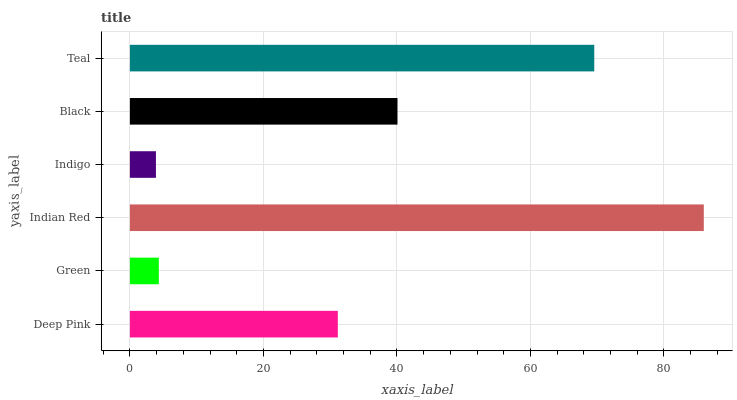Is Indigo the minimum?
Answer yes or no. Yes. Is Indian Red the maximum?
Answer yes or no. Yes. Is Green the minimum?
Answer yes or no. No. Is Green the maximum?
Answer yes or no. No. Is Deep Pink greater than Green?
Answer yes or no. Yes. Is Green less than Deep Pink?
Answer yes or no. Yes. Is Green greater than Deep Pink?
Answer yes or no. No. Is Deep Pink less than Green?
Answer yes or no. No. Is Black the high median?
Answer yes or no. Yes. Is Deep Pink the low median?
Answer yes or no. Yes. Is Indian Red the high median?
Answer yes or no. No. Is Indigo the low median?
Answer yes or no. No. 